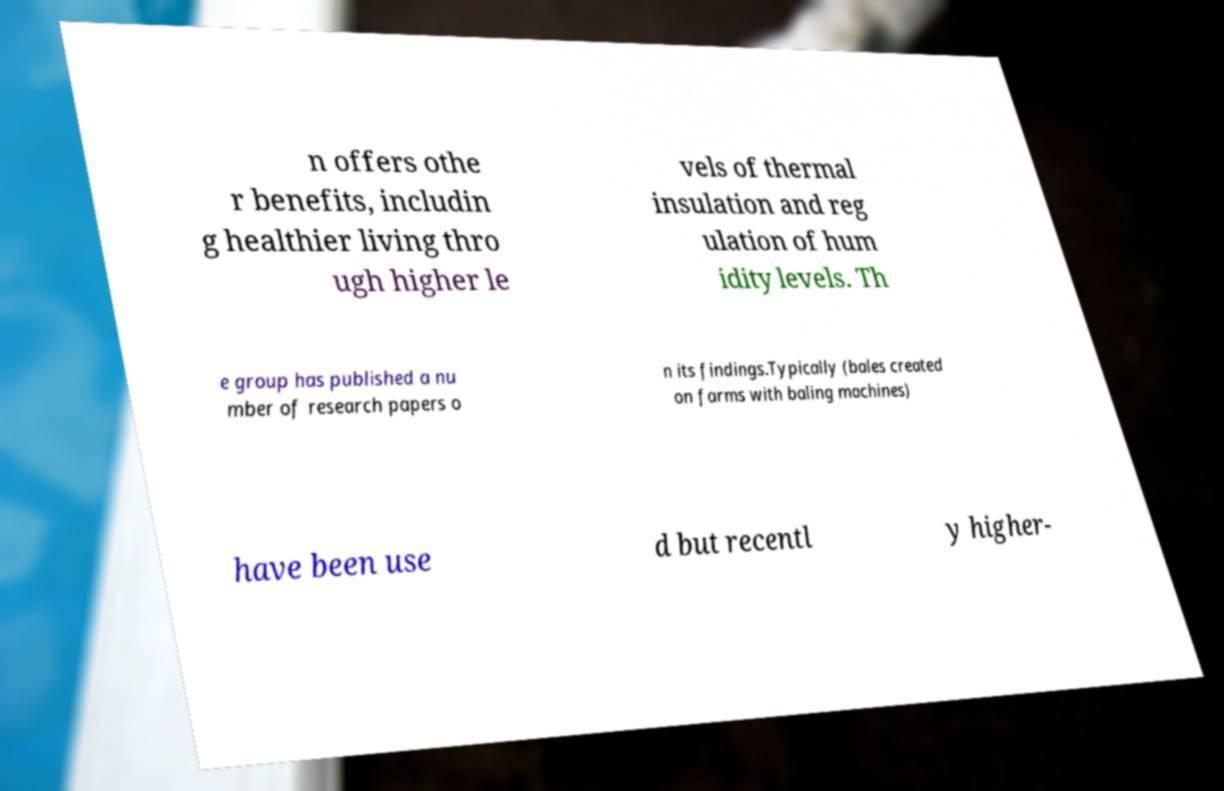For documentation purposes, I need the text within this image transcribed. Could you provide that? n offers othe r benefits, includin g healthier living thro ugh higher le vels of thermal insulation and reg ulation of hum idity levels. Th e group has published a nu mber of research papers o n its findings.Typically (bales created on farms with baling machines) have been use d but recentl y higher- 